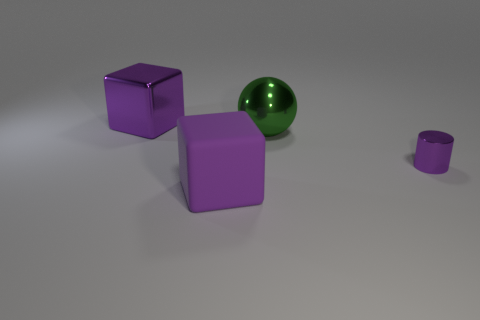There is a big cube that is behind the purple thing on the right side of the big purple matte block; what is it made of?
Ensure brevity in your answer.  Metal. Are there any things behind the green thing?
Make the answer very short. Yes. Are there more large purple blocks that are left of the big matte cube than gray matte things?
Your answer should be very brief. Yes. Is there a metallic sphere that has the same color as the tiny shiny cylinder?
Your response must be concise. No. The metallic block that is the same size as the green object is what color?
Offer a terse response. Purple. There is a large shiny object right of the big rubber thing; is there a purple shiny object on the right side of it?
Offer a very short reply. Yes. What is the material of the thing that is on the right side of the big metal ball?
Keep it short and to the point. Metal. Do the cylinder that is in front of the big green sphere and the purple block that is behind the small shiny cylinder have the same material?
Provide a succinct answer. Yes. Are there an equal number of tiny cylinders that are to the left of the big purple metal object and big purple cubes behind the tiny purple object?
Make the answer very short. No. How many tiny purple cylinders have the same material as the large green object?
Give a very brief answer. 1. 